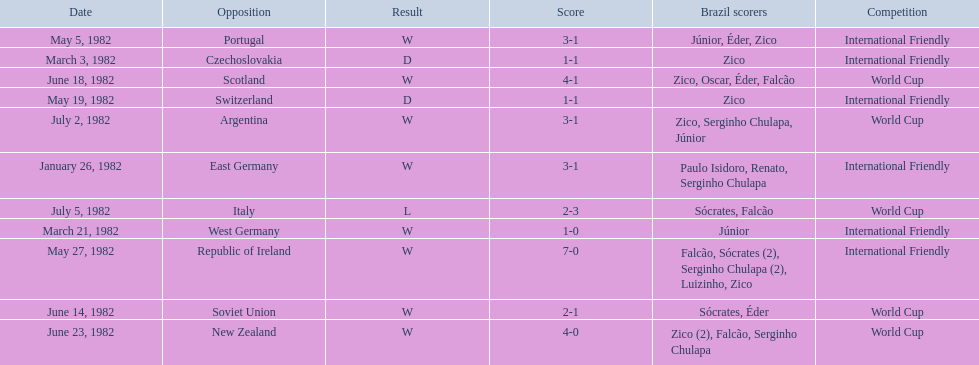How many goals did brazil score against the soviet union? 2-1. How many goals did brazil score against portugal? 3-1. Did brazil score more goals against portugal or the soviet union? Portugal. 